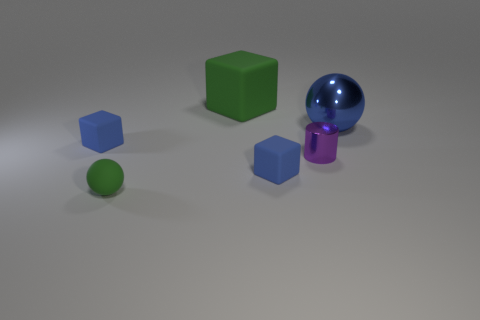There is a blue thing that is behind the small cube on the left side of the block that is to the right of the big green rubber cube; what shape is it?
Make the answer very short. Sphere. Is the number of blocks that are in front of the big blue metal ball greater than the number of cylinders?
Provide a succinct answer. Yes. There is a blue shiny thing; does it have the same shape as the small blue rubber thing in front of the purple metal cylinder?
Make the answer very short. No. There is a object that is the same color as the big rubber block; what is its shape?
Provide a short and direct response. Sphere. What number of purple things are to the left of the green rubber object that is behind the ball on the right side of the green matte cube?
Your answer should be very brief. 0. There is a matte sphere that is the same size as the shiny cylinder; what is its color?
Your answer should be compact. Green. What size is the object in front of the small cube that is right of the large rubber cube?
Offer a terse response. Small. There is a matte cube that is the same color as the small sphere; what is its size?
Your answer should be very brief. Large. What number of other things are the same size as the blue ball?
Ensure brevity in your answer.  1. How many balls are there?
Provide a succinct answer. 2. 